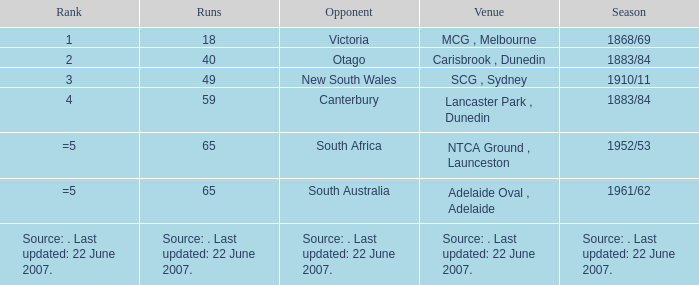Which race involves a rival of canterbury? 59.0. Help me parse the entirety of this table. {'header': ['Rank', 'Runs', 'Opponent', 'Venue', 'Season'], 'rows': [['1', '18', 'Victoria', 'MCG , Melbourne', '1868/69'], ['2', '40', 'Otago', 'Carisbrook , Dunedin', '1883/84'], ['3', '49', 'New South Wales', 'SCG , Sydney', '1910/11'], ['4', '59', 'Canterbury', 'Lancaster Park , Dunedin', '1883/84'], ['=5', '65', 'South Africa', 'NTCA Ground , Launceston', '1952/53'], ['=5', '65', 'South Australia', 'Adelaide Oval , Adelaide', '1961/62'], ['Source: . Last updated: 22 June 2007.', 'Source: . Last updated: 22 June 2007.', 'Source: . Last updated: 22 June 2007.', 'Source: . Last updated: 22 June 2007.', 'Source: . Last updated: 22 June 2007.']]} 